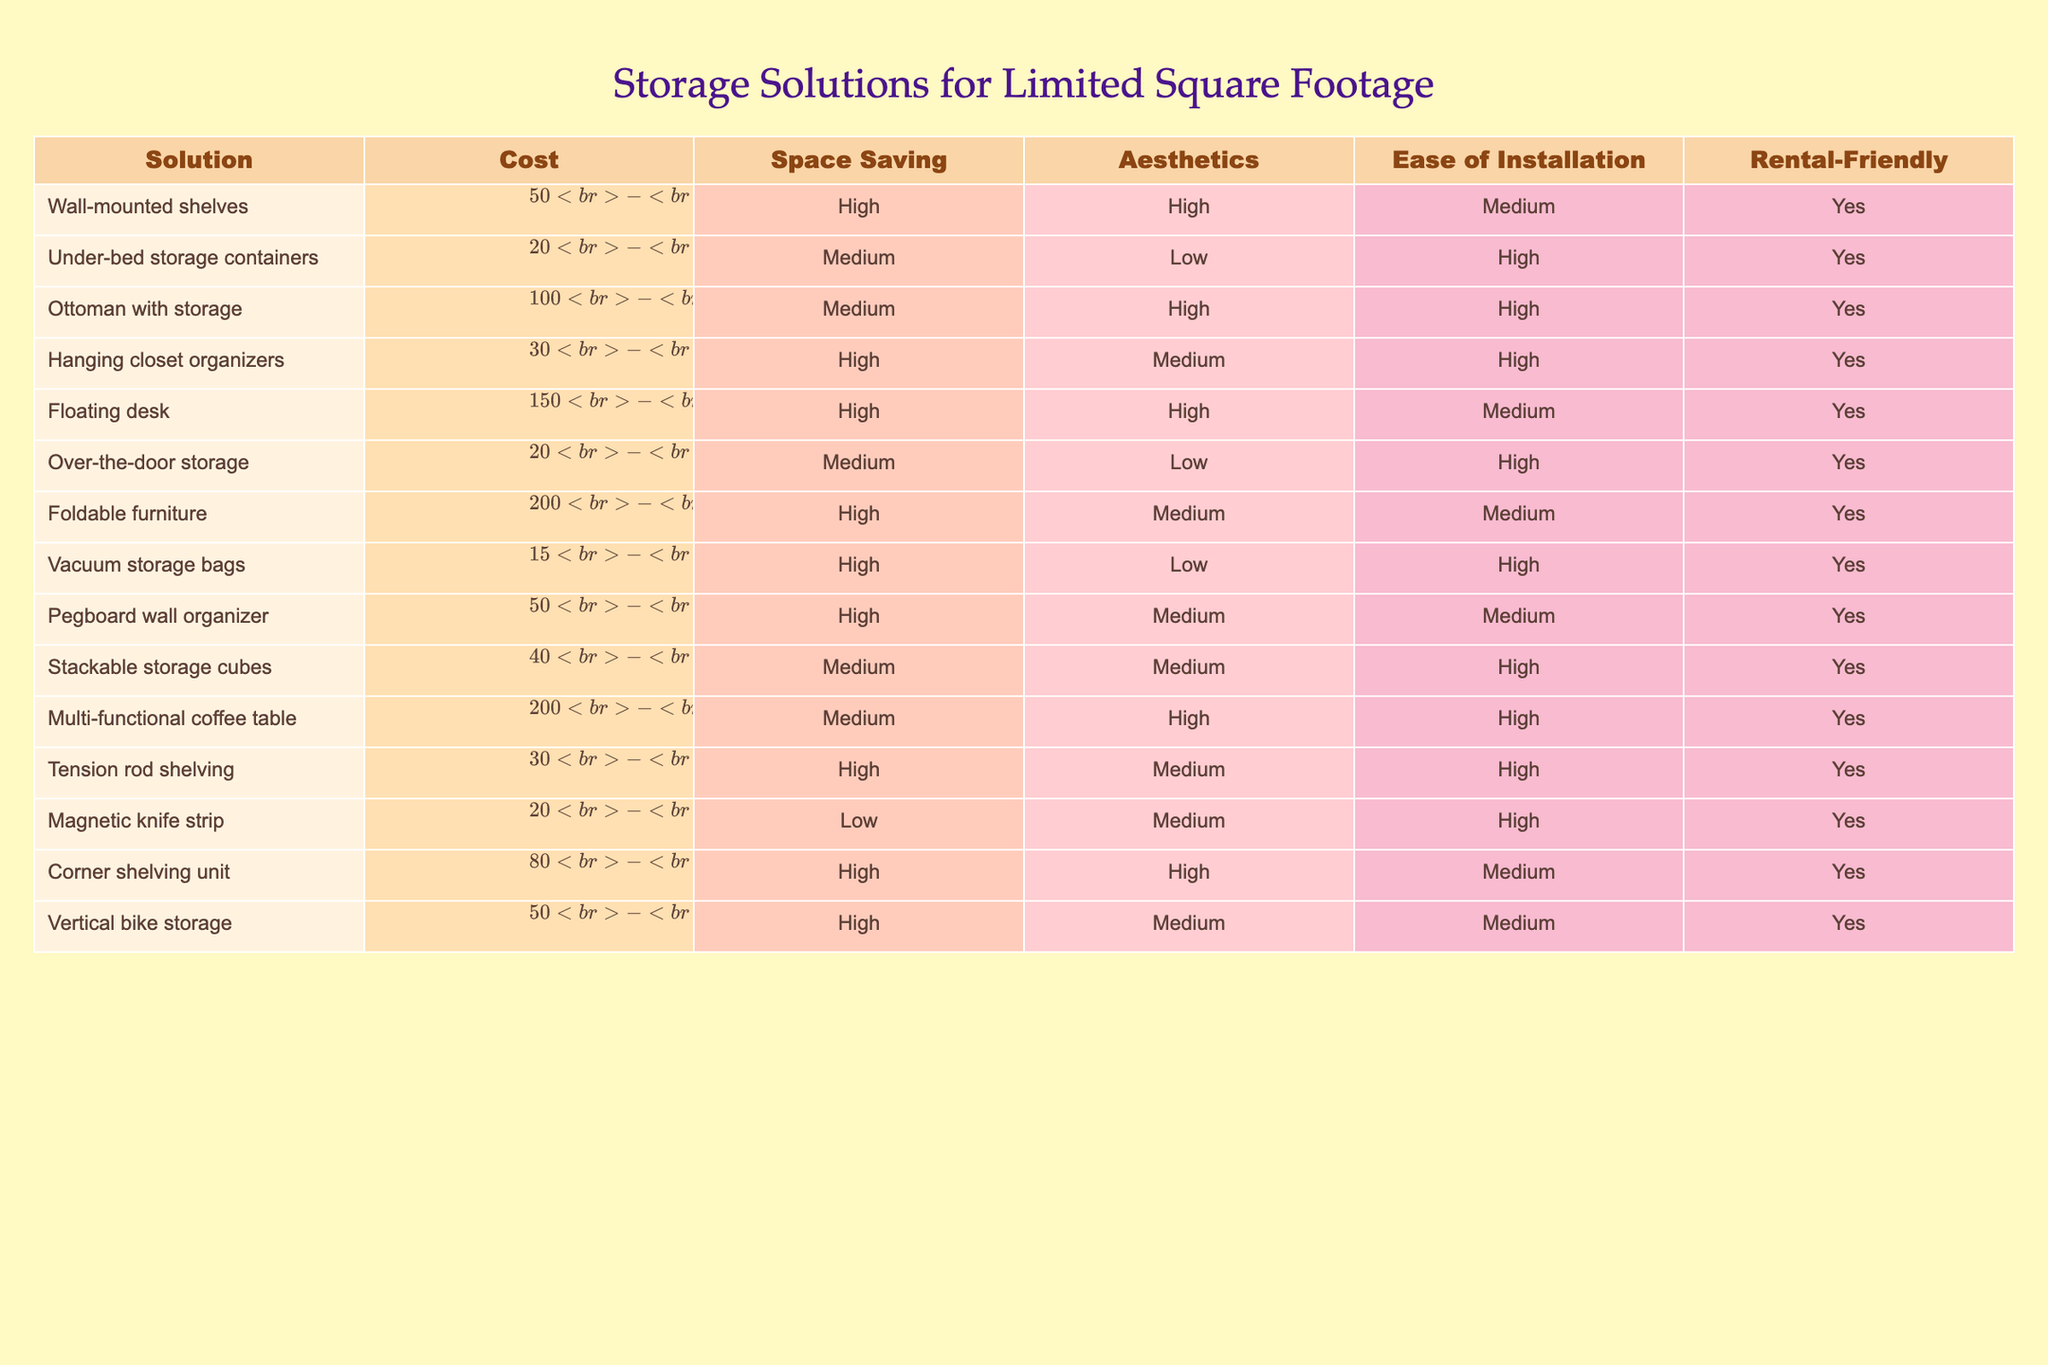What is the cost range for wall-mounted shelves? The table lists the cost range for wall-mounted shelves as "$50-$200". Thus, the entire range indicates the minimum and maximum price.
Answer: $50-$200 Which storage solution has the highest cost? By examining the cost column, the foldable furniture has the highest cost range at "$200-$600".
Answer: $200-$600 Is it easy to install a hanging closet organizer? The ease of installation for a hanging closet organizer is rated as "High" in the table, indicating that it is easy to install.
Answer: Yes How many storage solutions offer high space saving? The table shows that wall-mounted shelves, hanging closet organizers, folding furniture, vacuum storage bags, tension rod shelving, corner shelving unit, and vertical bike storage have "High" for space saving. There are a total of 7 solutions with high space saving.
Answer: 7 What is the average cost of solutions that are rental-friendly? The rental-friendly solutions have the following cost ranges: Wall-mounted shelves ($50-$200), Under-bed storage containers ($20-$100), Ottoman with storage ($100-$300), Hanging closet organizers ($30-$80), Floating desk ($150-$400), Over-the-door storage ($20-$60), Foldable furniture ($200-$600), Vacuum storage bags ($15-$40), Pegboard wall organizer ($50-$150), Stackable storage cubes ($40-$120), Multi-functional coffee table ($200-$500), Tension rod shelving ($30-$100), Magnetic knife strip ($20-$50), Corner shelving unit ($80-$250), Vertical bike storage ($50-$150). To calculate the average cost, I sum the lower and upper bounds for all solutions and divide by the number of solutions. The total lower bounds sum to 1,... and upper bounds sum to 2,... The average cost is then $50-$200.
Answer: $145 Is the ottoman with storage both aesthetic and easy to install? The aesthetics rating for the ottoman with storage is "High", while the ease of installation is rated as "High". Therefore, both aspects meet the criteria asked.
Answer: Yes How many storage solutions have a low aesthetic rating? Under the aesthetics column, there are two storage solutions that are listed as "Low": Under-bed storage containers and vacuum storage bags.
Answer: 2 Which solutions offer medium ease of installation? According to the table, the solutions that offer medium ease of installation are: wall-mounted shelves, floating desk, folding furniture, pegboard wall organizer, vertical bike storage, and corner shelving unit. There are a total of 6 solutions listed with medium ease of installation.
Answer: 6 